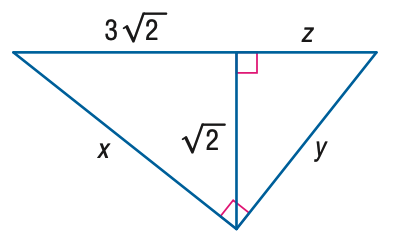Answer the mathemtical geometry problem and directly provide the correct option letter.
Question: Find x.
Choices: A: 2 \sqrt { 2 } B: 3 \sqrt { 2 } C: 2 \sqrt { 5 } D: 3 \sqrt { 5 } C 